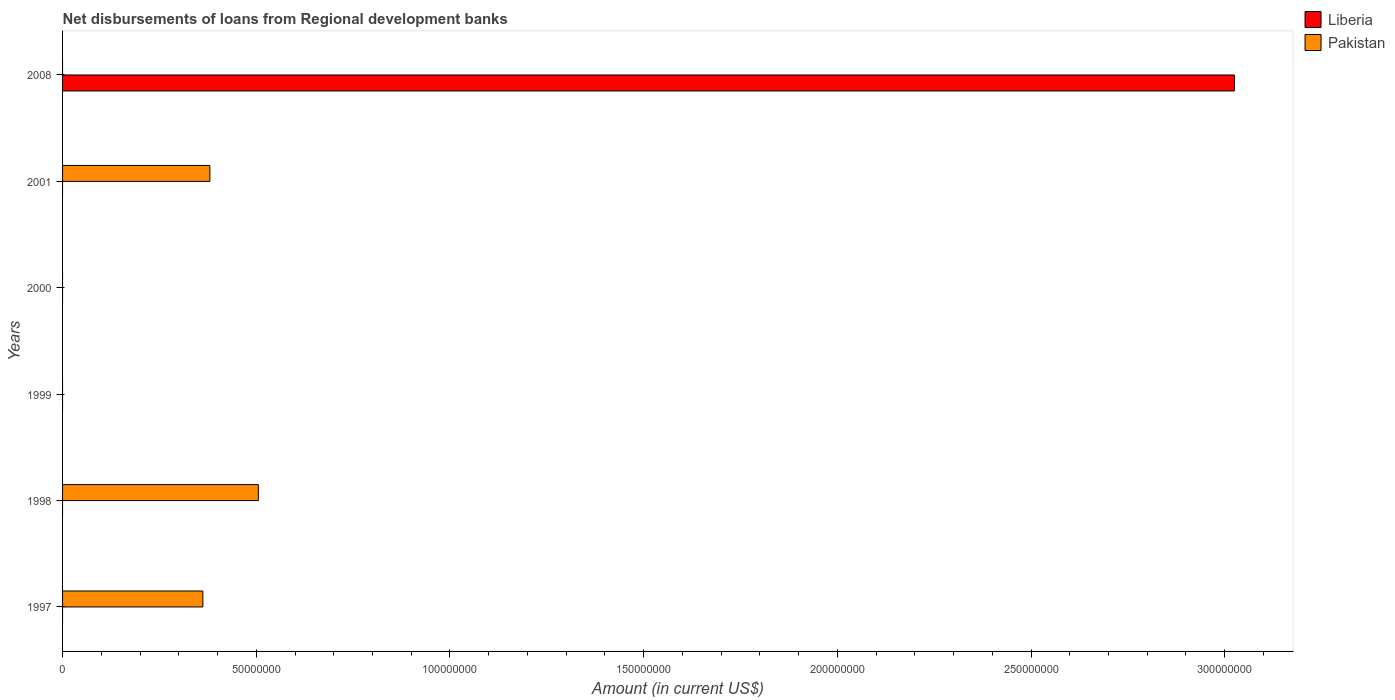In how many cases, is the number of bars for a given year not equal to the number of legend labels?
Give a very brief answer. 6. Across all years, what is the maximum amount of disbursements of loans from regional development banks in Liberia?
Your answer should be very brief. 3.03e+08. Across all years, what is the minimum amount of disbursements of loans from regional development banks in Pakistan?
Provide a succinct answer. 0. In which year was the amount of disbursements of loans from regional development banks in Pakistan maximum?
Provide a short and direct response. 1998. What is the total amount of disbursements of loans from regional development banks in Liberia in the graph?
Provide a succinct answer. 3.03e+08. What is the difference between the amount of disbursements of loans from regional development banks in Pakistan in 1997 and that in 1998?
Give a very brief answer. -1.43e+07. What is the difference between the amount of disbursements of loans from regional development banks in Pakistan in 2000 and the amount of disbursements of loans from regional development banks in Liberia in 1998?
Ensure brevity in your answer.  0. What is the average amount of disbursements of loans from regional development banks in Liberia per year?
Offer a terse response. 5.04e+07. In how many years, is the amount of disbursements of loans from regional development banks in Pakistan greater than 50000000 US$?
Make the answer very short. 1. What is the difference between the highest and the second highest amount of disbursements of loans from regional development banks in Pakistan?
Keep it short and to the point. 1.25e+07. What is the difference between the highest and the lowest amount of disbursements of loans from regional development banks in Liberia?
Your answer should be very brief. 3.03e+08. Is the sum of the amount of disbursements of loans from regional development banks in Pakistan in 1997 and 1998 greater than the maximum amount of disbursements of loans from regional development banks in Liberia across all years?
Provide a succinct answer. No. How many bars are there?
Give a very brief answer. 4. How many years are there in the graph?
Offer a very short reply. 6. Does the graph contain any zero values?
Your response must be concise. Yes. Where does the legend appear in the graph?
Offer a terse response. Top right. What is the title of the graph?
Offer a very short reply. Net disbursements of loans from Regional development banks. What is the label or title of the X-axis?
Give a very brief answer. Amount (in current US$). What is the Amount (in current US$) of Pakistan in 1997?
Your answer should be very brief. 3.62e+07. What is the Amount (in current US$) in Pakistan in 1998?
Offer a terse response. 5.05e+07. What is the Amount (in current US$) in Liberia in 2000?
Keep it short and to the point. 0. What is the Amount (in current US$) of Liberia in 2001?
Your response must be concise. 0. What is the Amount (in current US$) of Pakistan in 2001?
Offer a terse response. 3.80e+07. What is the Amount (in current US$) in Liberia in 2008?
Keep it short and to the point. 3.03e+08. What is the Amount (in current US$) in Pakistan in 2008?
Your response must be concise. 0. Across all years, what is the maximum Amount (in current US$) in Liberia?
Offer a terse response. 3.03e+08. Across all years, what is the maximum Amount (in current US$) of Pakistan?
Offer a terse response. 5.05e+07. Across all years, what is the minimum Amount (in current US$) in Liberia?
Make the answer very short. 0. What is the total Amount (in current US$) of Liberia in the graph?
Ensure brevity in your answer.  3.03e+08. What is the total Amount (in current US$) in Pakistan in the graph?
Provide a succinct answer. 1.25e+08. What is the difference between the Amount (in current US$) in Pakistan in 1997 and that in 1998?
Make the answer very short. -1.43e+07. What is the difference between the Amount (in current US$) in Pakistan in 1997 and that in 2001?
Your response must be concise. -1.80e+06. What is the difference between the Amount (in current US$) of Pakistan in 1998 and that in 2001?
Provide a short and direct response. 1.25e+07. What is the average Amount (in current US$) in Liberia per year?
Give a very brief answer. 5.04e+07. What is the average Amount (in current US$) in Pakistan per year?
Offer a terse response. 2.08e+07. What is the ratio of the Amount (in current US$) in Pakistan in 1997 to that in 1998?
Your response must be concise. 0.72. What is the ratio of the Amount (in current US$) of Pakistan in 1997 to that in 2001?
Your answer should be very brief. 0.95. What is the ratio of the Amount (in current US$) of Pakistan in 1998 to that in 2001?
Offer a terse response. 1.33. What is the difference between the highest and the second highest Amount (in current US$) in Pakistan?
Offer a very short reply. 1.25e+07. What is the difference between the highest and the lowest Amount (in current US$) in Liberia?
Ensure brevity in your answer.  3.03e+08. What is the difference between the highest and the lowest Amount (in current US$) of Pakistan?
Keep it short and to the point. 5.05e+07. 